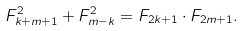<formula> <loc_0><loc_0><loc_500><loc_500>F _ { k + m + 1 } ^ { 2 } + F _ { m - k } ^ { 2 } = F _ { 2 k + 1 } \cdot F _ { 2 m + 1 } .</formula> 